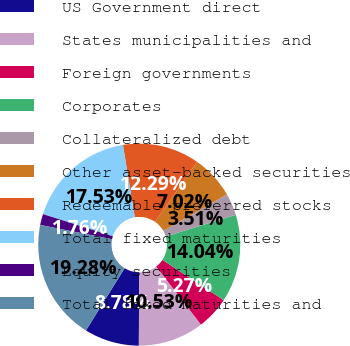Convert chart. <chart><loc_0><loc_0><loc_500><loc_500><pie_chart><fcel>US Government direct<fcel>States municipalities and<fcel>Foreign governments<fcel>Corporates<fcel>Collateralized debt<fcel>Other asset-backed securities<fcel>Redeemable preferred stocks<fcel>Total fixed maturities<fcel>Equity securities<fcel>Total fixed maturities and<nl><fcel>8.78%<fcel>10.53%<fcel>5.27%<fcel>14.04%<fcel>3.51%<fcel>7.02%<fcel>12.29%<fcel>17.53%<fcel>1.76%<fcel>19.28%<nl></chart> 